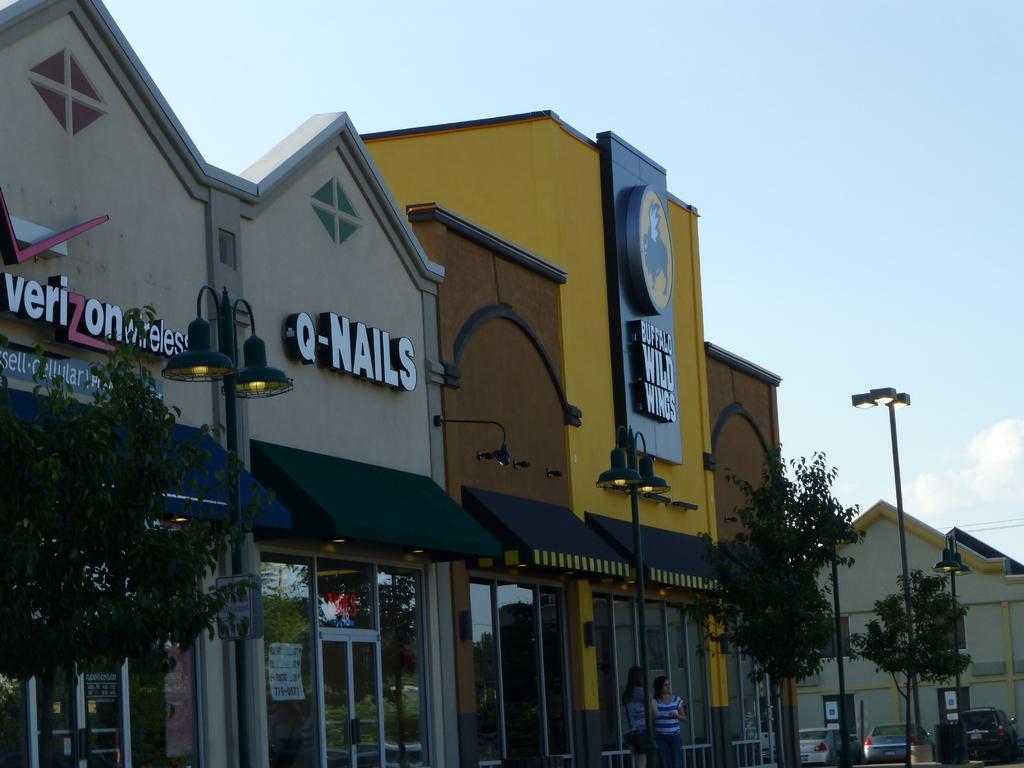Can you describe this image briefly? In this picture I can see there are some buildings, trees, cars moving on the road. The sky is clear. 